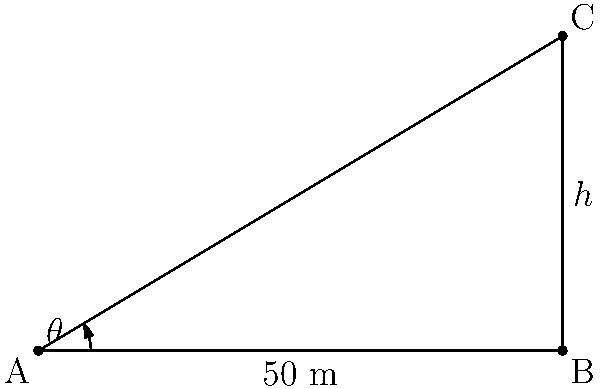In a rapidly growing urban area, you're analyzing the height of new skyscrapers. From a distance of 50 meters from the base of a skyscraper, you measure the angle of elevation to its top as 31°. What is the height of the skyscraper to the nearest meter? Let's approach this step-by-step:

1) We can model this situation as a right-angled triangle, where:
   - The base of the triangle is the distance from the observer to the skyscraper (50 m)
   - The height of the triangle is the height of the skyscraper (h)
   - The angle of elevation is the angle between the base and the line of sight (31°)

2) In this right-angled triangle, we know:
   - The adjacent side (50 m)
   - The angle (31°)
   - We need to find the opposite side (h)

3) This scenario calls for the use of the tangent function:

   $$\tan \theta = \frac{\text{opposite}}{\text{adjacent}} = \frac{h}{50}$$

4) Rearranging this equation:

   $$h = 50 \tan \theta$$

5) Plugging in our known values:

   $$h = 50 \tan 31°$$

6) Using a calculator (or trigonometric tables):

   $$h = 50 * 0.6008 = 30.04 \text{ meters}$$

7) Rounding to the nearest meter:

   $$h \approx 30 \text{ meters}$$
Answer: 30 meters 